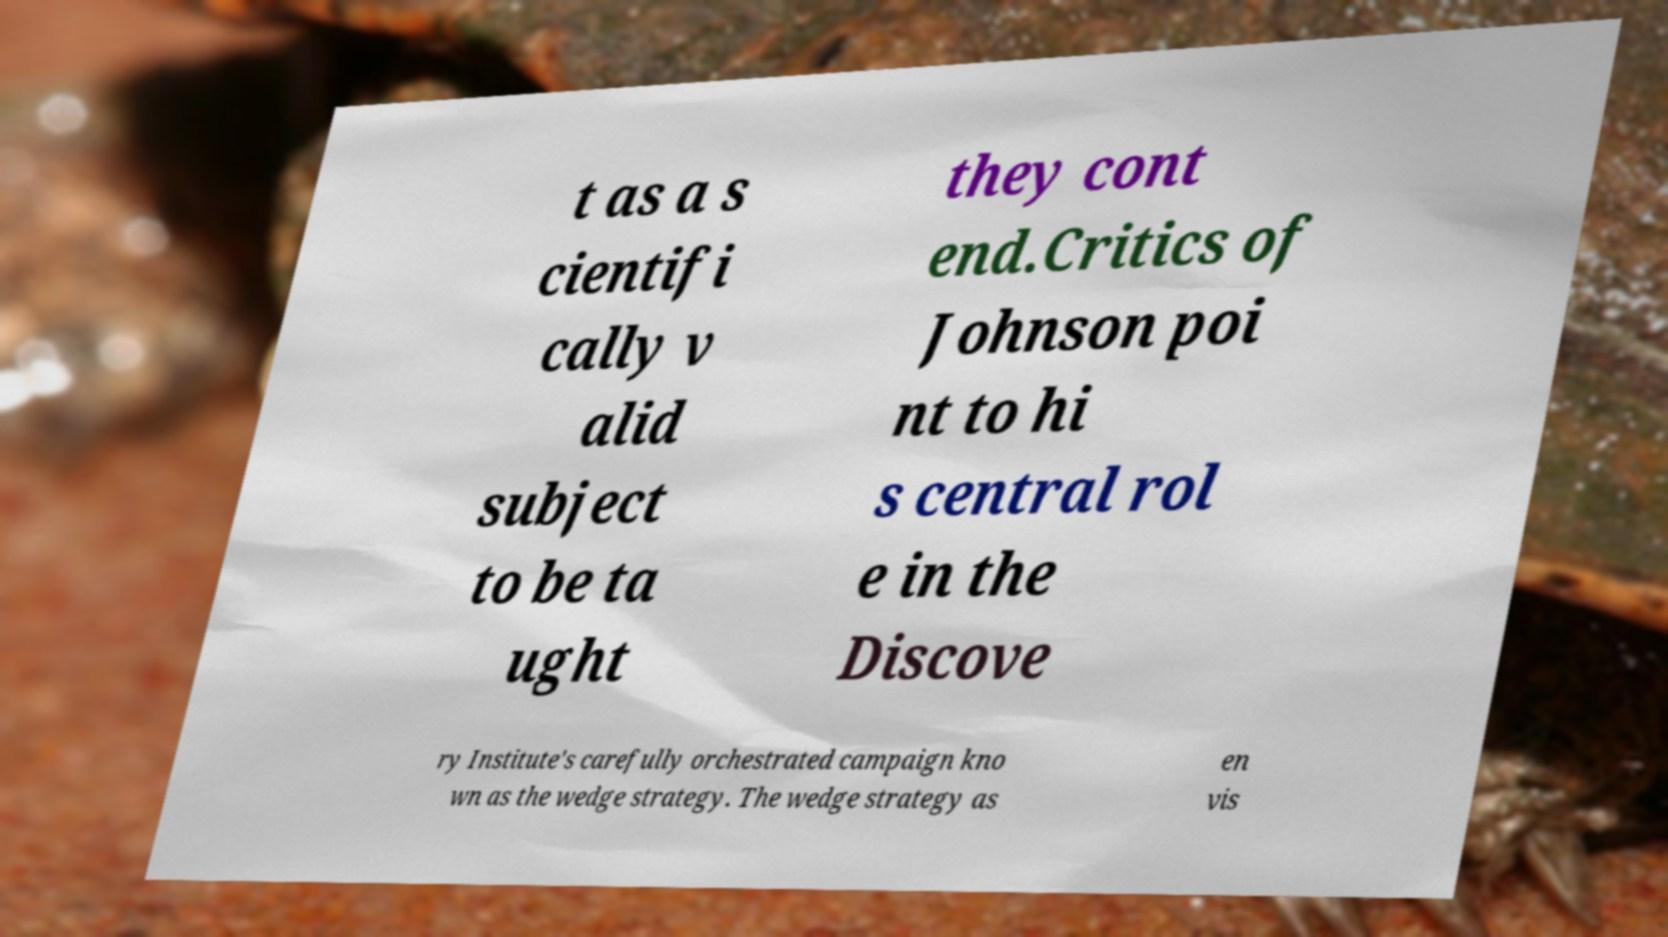For documentation purposes, I need the text within this image transcribed. Could you provide that? t as a s cientifi cally v alid subject to be ta ught they cont end.Critics of Johnson poi nt to hi s central rol e in the Discove ry Institute's carefully orchestrated campaign kno wn as the wedge strategy. The wedge strategy as en vis 